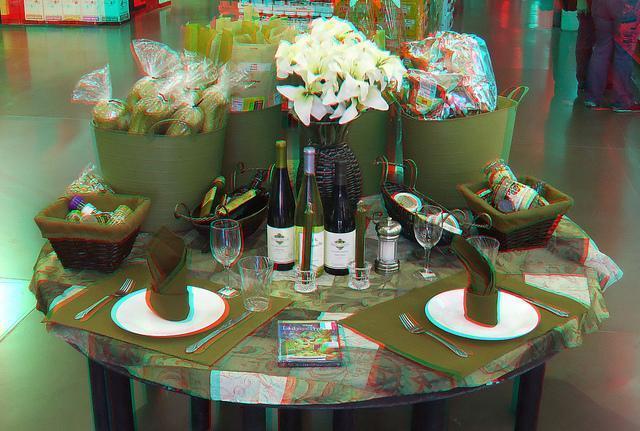How many bottles are there?
Give a very brief answer. 4. How many potted plants are in the picture?
Give a very brief answer. 1. 